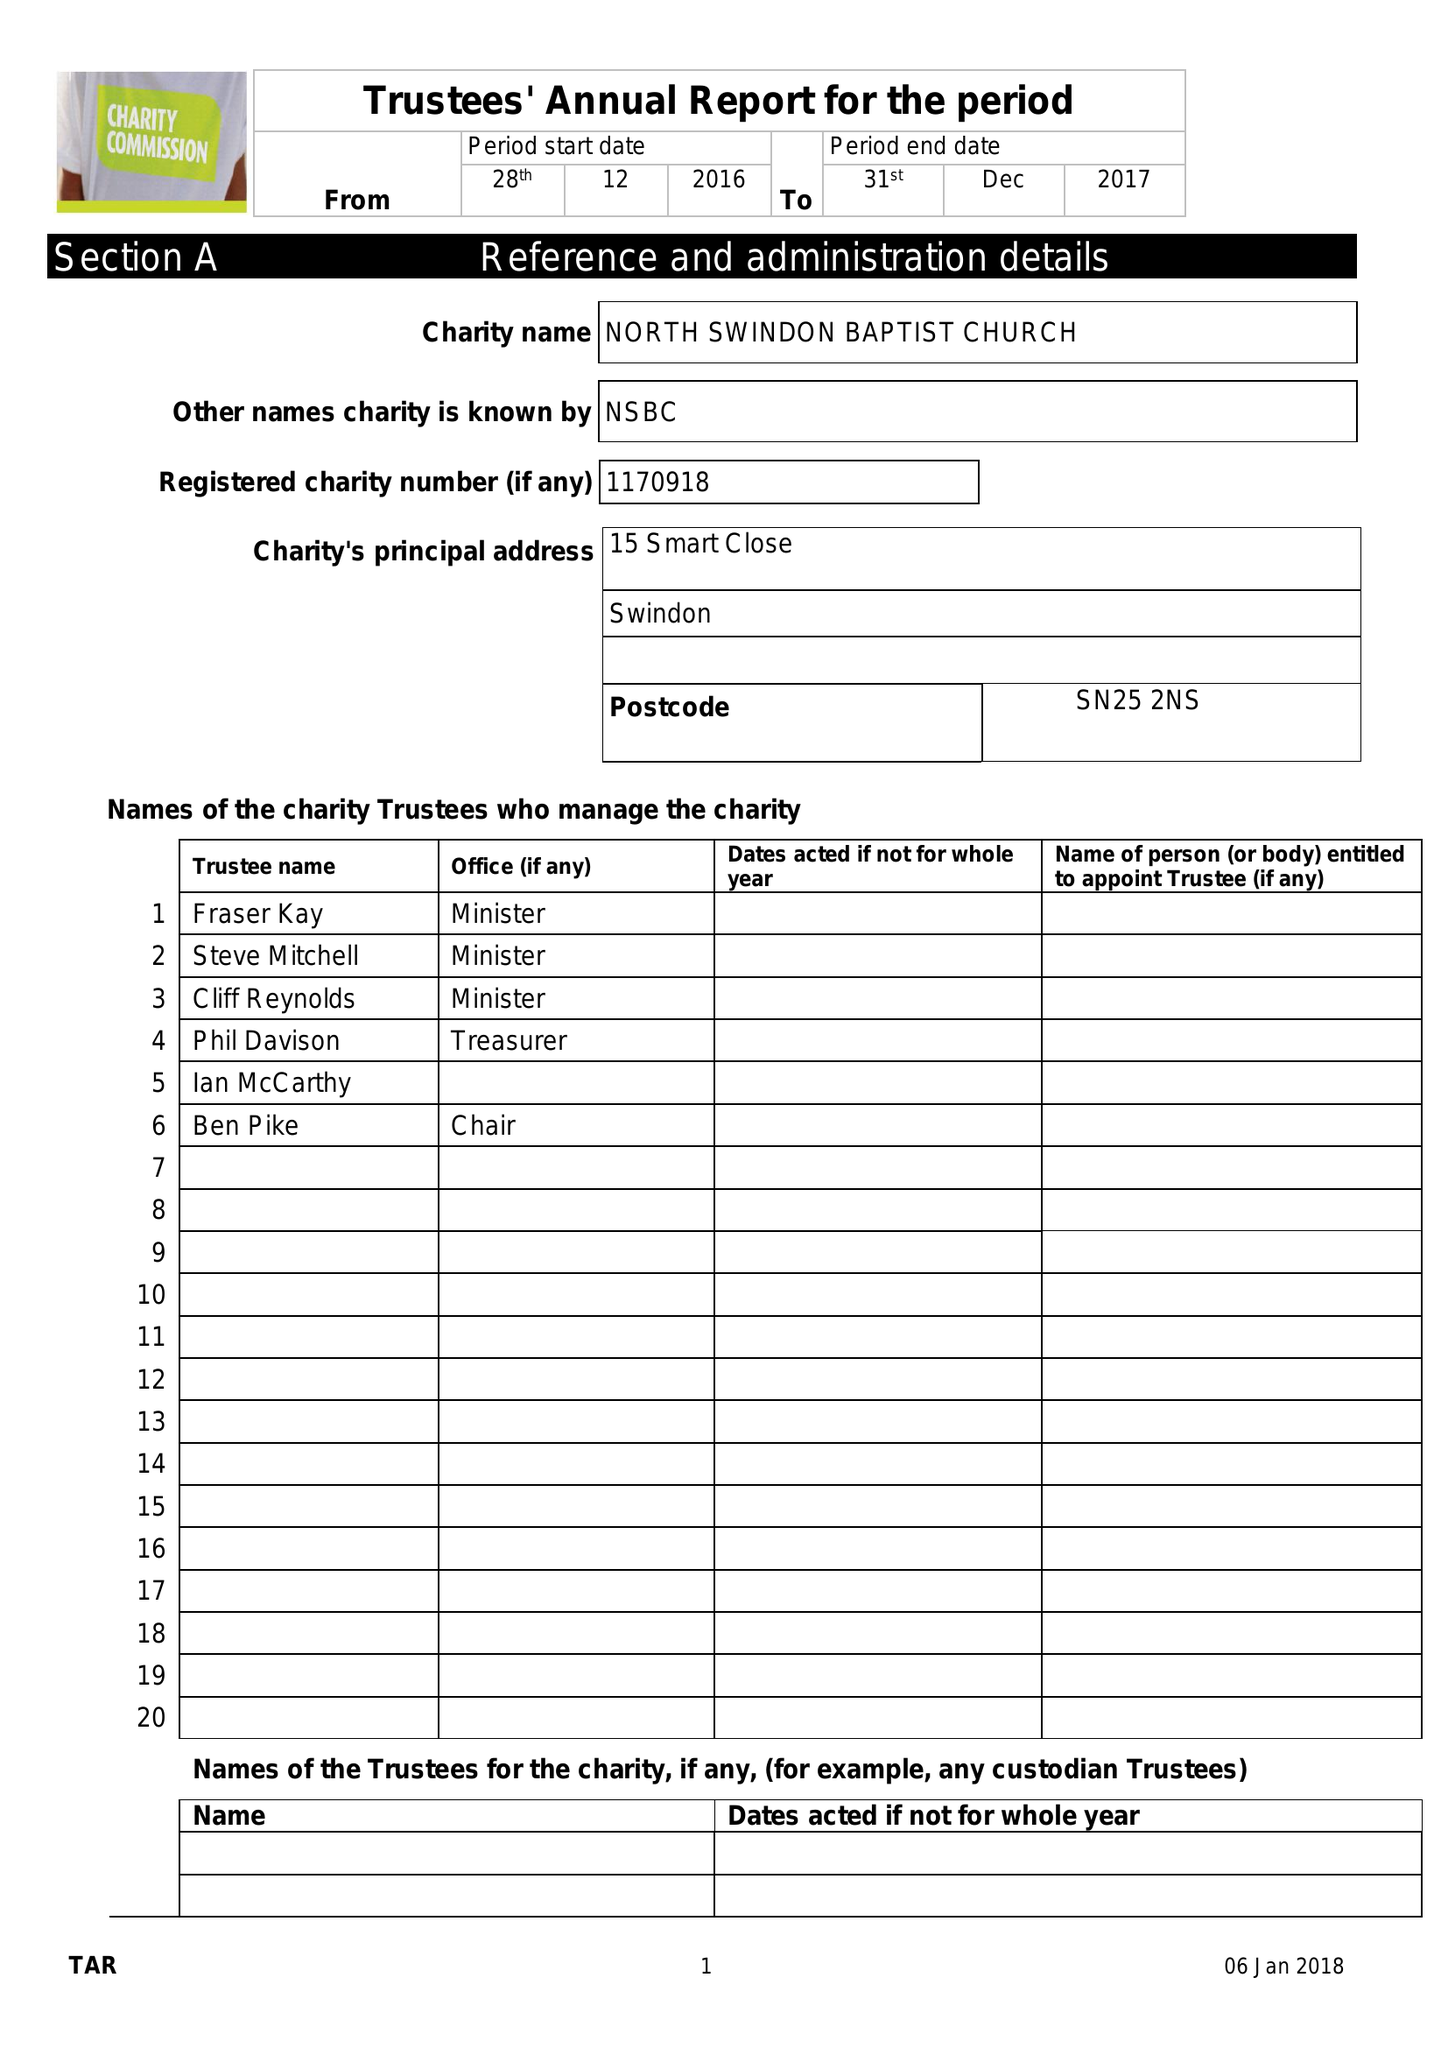What is the value for the charity_number?
Answer the question using a single word or phrase. 1170918 